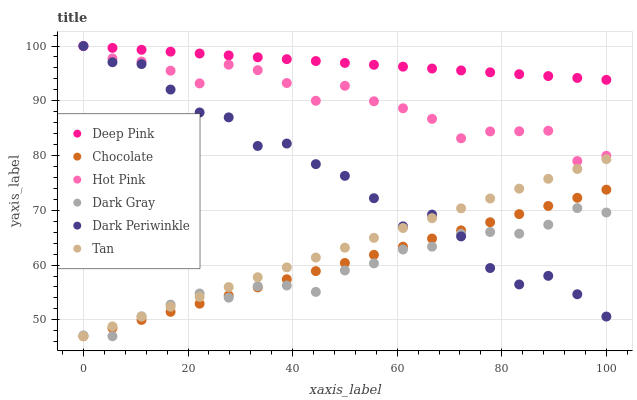Does Dark Gray have the minimum area under the curve?
Answer yes or no. Yes. Does Deep Pink have the maximum area under the curve?
Answer yes or no. Yes. Does Hot Pink have the minimum area under the curve?
Answer yes or no. No. Does Hot Pink have the maximum area under the curve?
Answer yes or no. No. Is Tan the smoothest?
Answer yes or no. Yes. Is Dark Periwinkle the roughest?
Answer yes or no. Yes. Is Hot Pink the smoothest?
Answer yes or no. No. Is Hot Pink the roughest?
Answer yes or no. No. Does Chocolate have the lowest value?
Answer yes or no. Yes. Does Hot Pink have the lowest value?
Answer yes or no. No. Does Dark Periwinkle have the highest value?
Answer yes or no. Yes. Does Chocolate have the highest value?
Answer yes or no. No. Is Dark Gray less than Hot Pink?
Answer yes or no. Yes. Is Deep Pink greater than Dark Gray?
Answer yes or no. Yes. Does Chocolate intersect Dark Periwinkle?
Answer yes or no. Yes. Is Chocolate less than Dark Periwinkle?
Answer yes or no. No. Is Chocolate greater than Dark Periwinkle?
Answer yes or no. No. Does Dark Gray intersect Hot Pink?
Answer yes or no. No. 